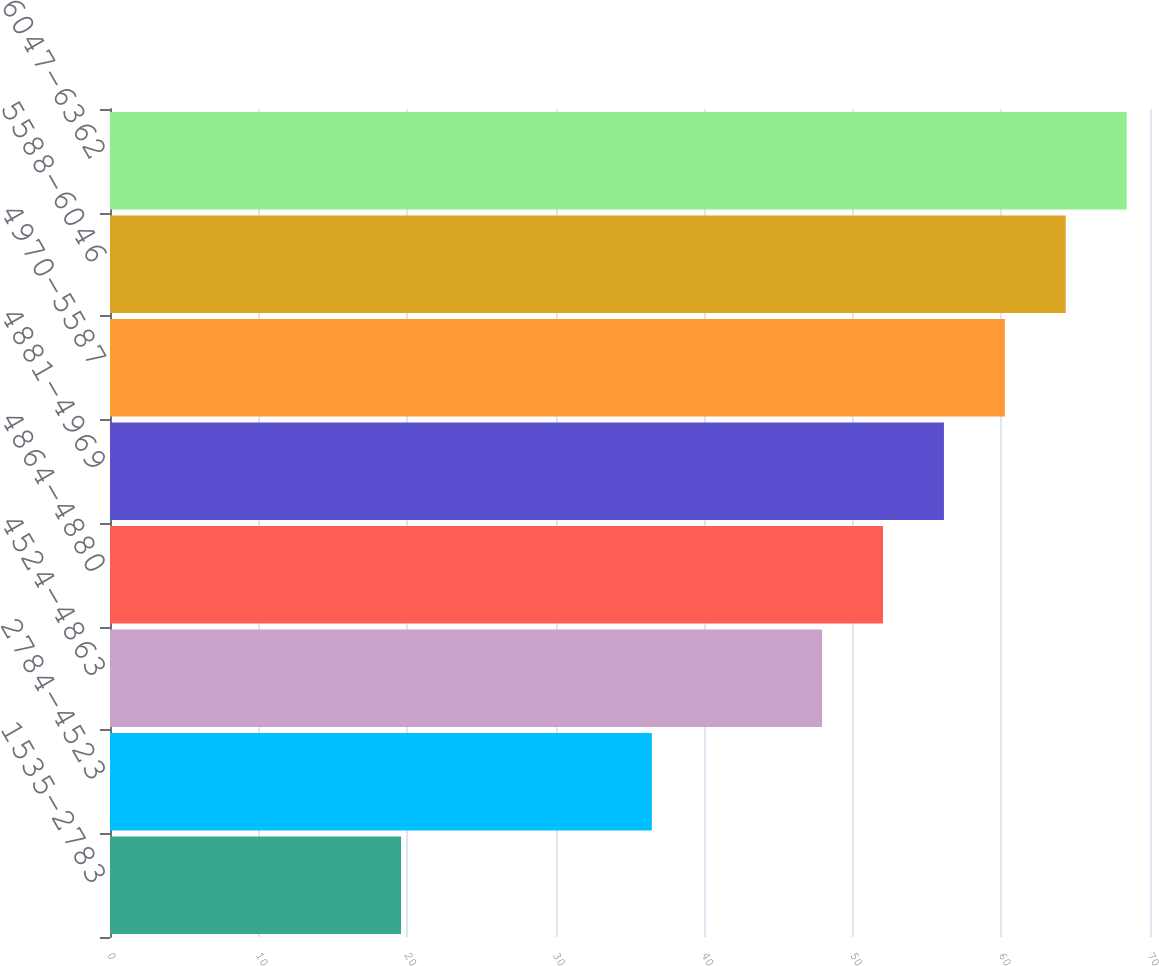Convert chart to OTSL. <chart><loc_0><loc_0><loc_500><loc_500><bar_chart><fcel>1535-2783<fcel>2784-4523<fcel>4524-4863<fcel>4864-4880<fcel>4881-4969<fcel>4970-5587<fcel>5588-6046<fcel>6047-6362<nl><fcel>19.59<fcel>36.47<fcel>47.93<fcel>52.03<fcel>56.13<fcel>60.23<fcel>64.33<fcel>68.43<nl></chart> 